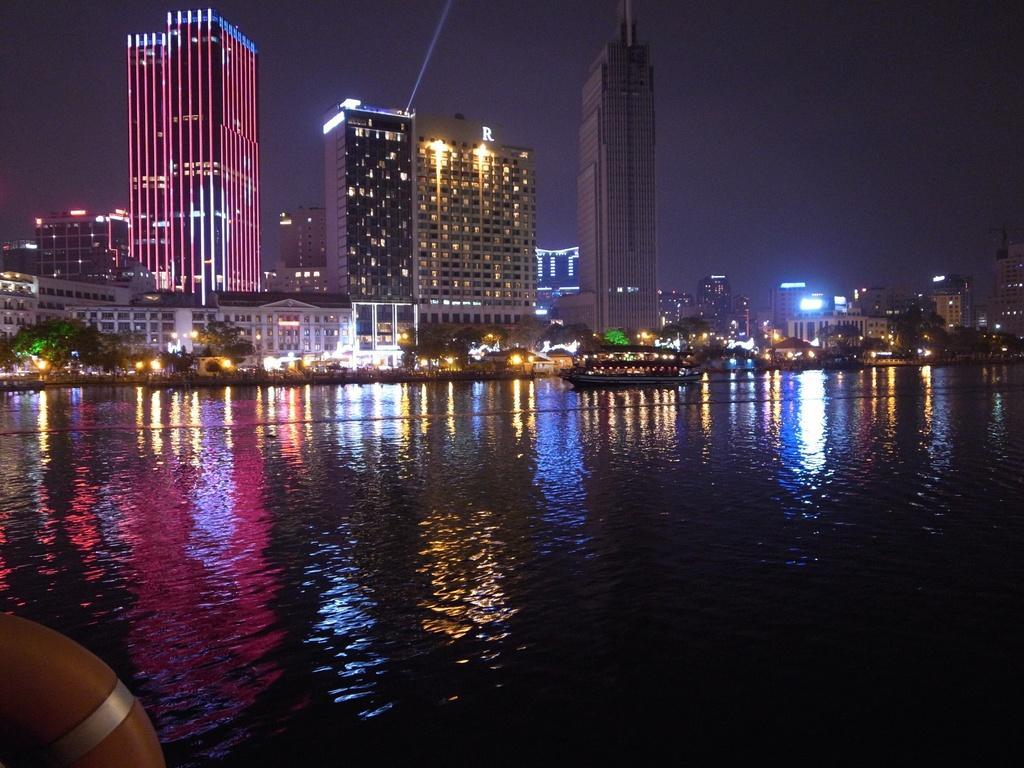How would you summarize this image in a sentence or two? In this picture we can see a swim tube, boat on water, buildings, trees, lights and in the background we can see the sky. 